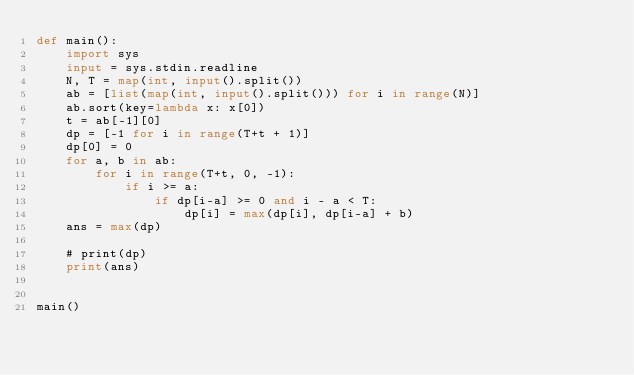Convert code to text. <code><loc_0><loc_0><loc_500><loc_500><_Python_>def main():
    import sys
    input = sys.stdin.readline
    N, T = map(int, input().split())
    ab = [list(map(int, input().split())) for i in range(N)]
    ab.sort(key=lambda x: x[0])
    t = ab[-1][0]
    dp = [-1 for i in range(T+t + 1)]
    dp[0] = 0
    for a, b in ab:
        for i in range(T+t, 0, -1):
            if i >= a:
                if dp[i-a] >= 0 and i - a < T:
                    dp[i] = max(dp[i], dp[i-a] + b)
    ans = max(dp)

    # print(dp)
    print(ans)


main()
</code> 